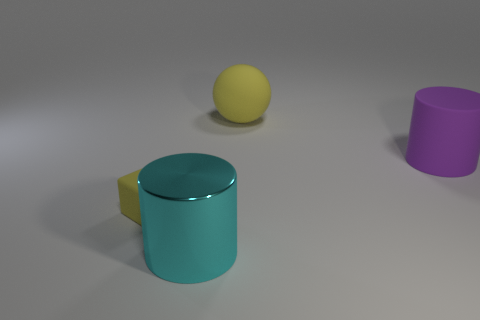Add 1 matte objects. How many objects exist? 5 Subtract all cubes. How many objects are left? 3 Subtract 0 green cylinders. How many objects are left? 4 Subtract all yellow cylinders. Subtract all purple cubes. How many cylinders are left? 2 Subtract all large cyan shiny objects. Subtract all large cyan objects. How many objects are left? 2 Add 1 cyan objects. How many cyan objects are left? 2 Add 4 big green matte balls. How many big green matte balls exist? 4 